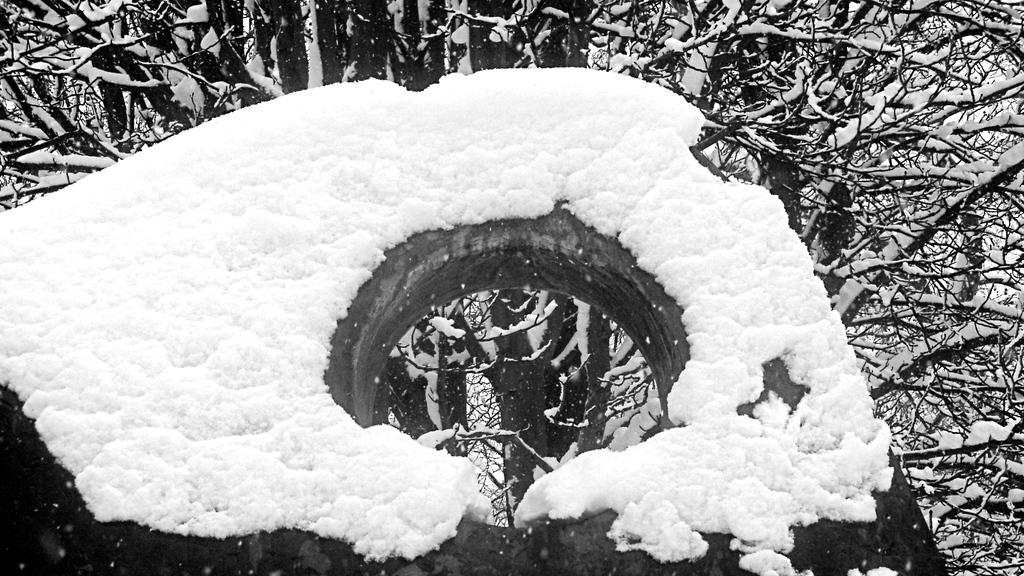What is covering the wall in the image? There is a wall covered with snow in the image. What can be seen in the background of the image? There are trees visible in the background of the image. What type of cushion is placed on the daughter's heart in the image? There is no daughter or cushion present in the image. 